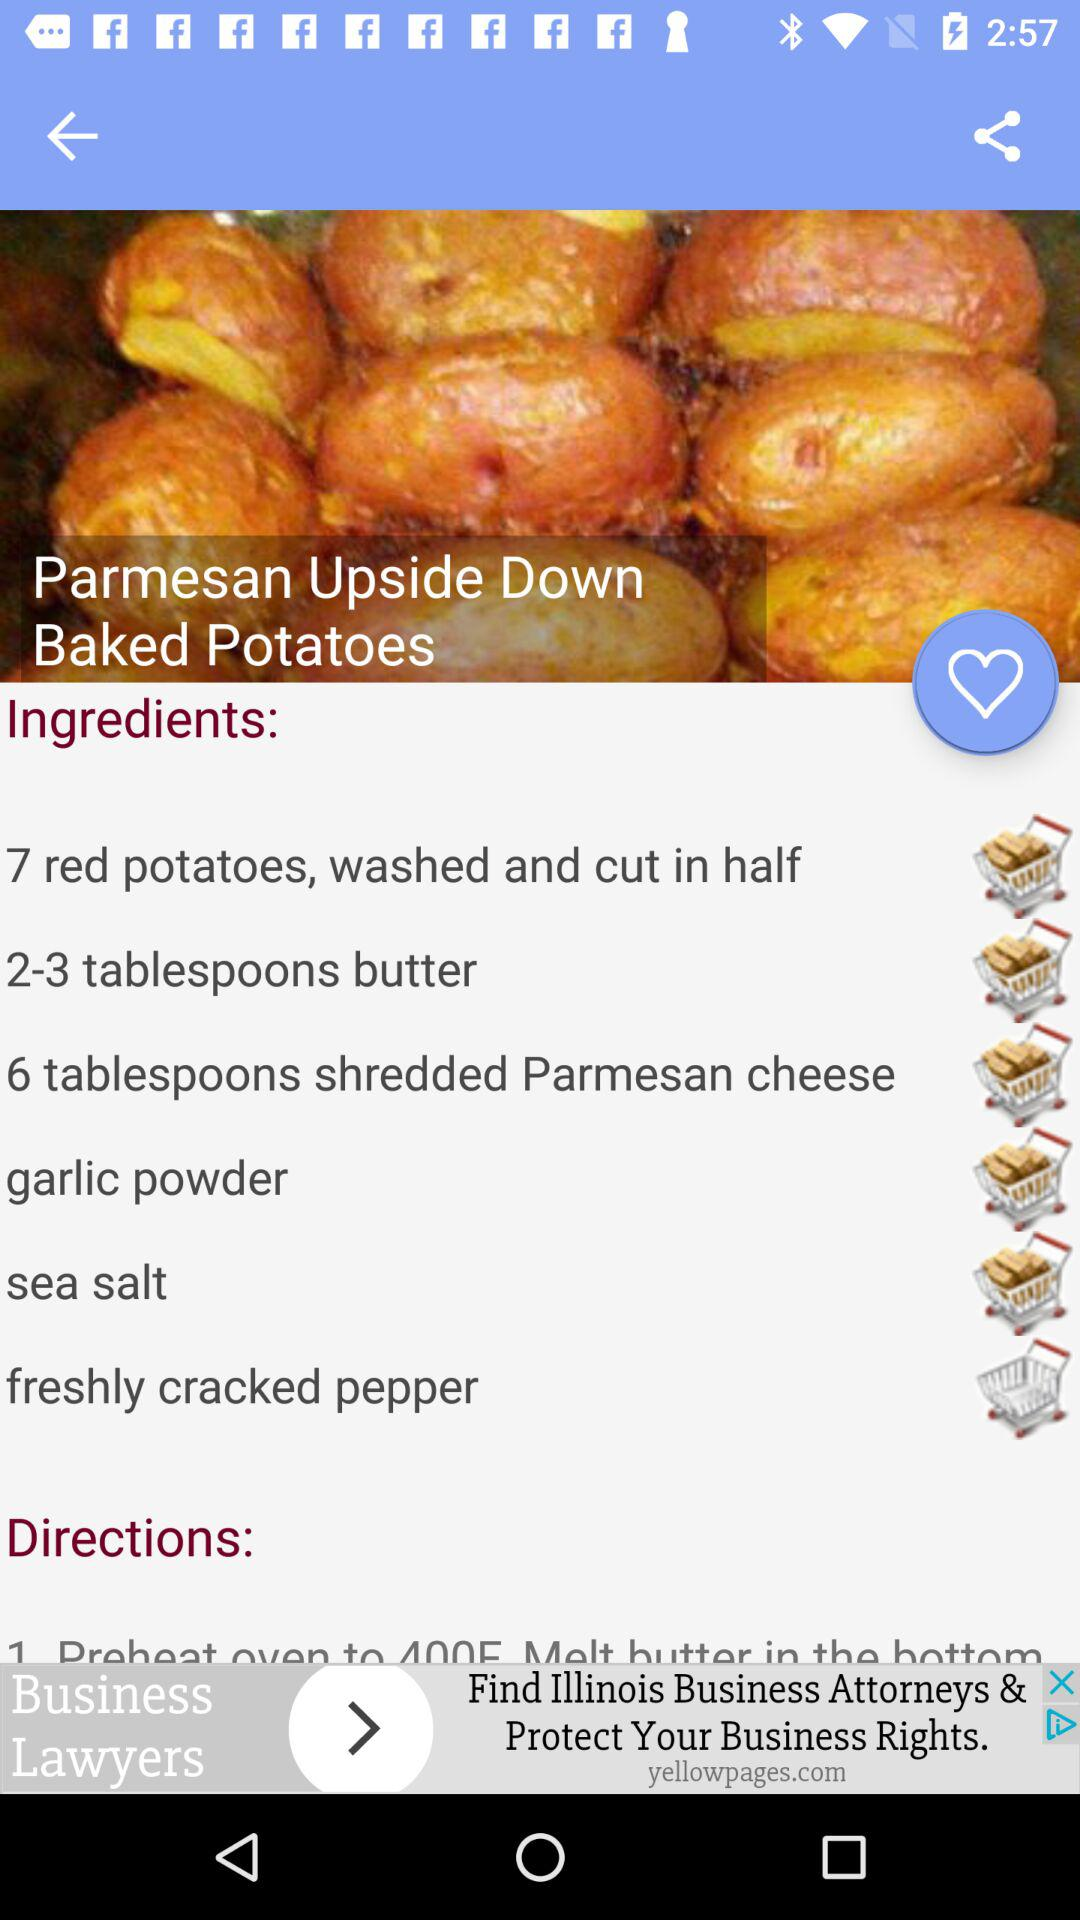What's the number of tablespoons of butter? The number of tablespoons of butter is 2 to 3. 